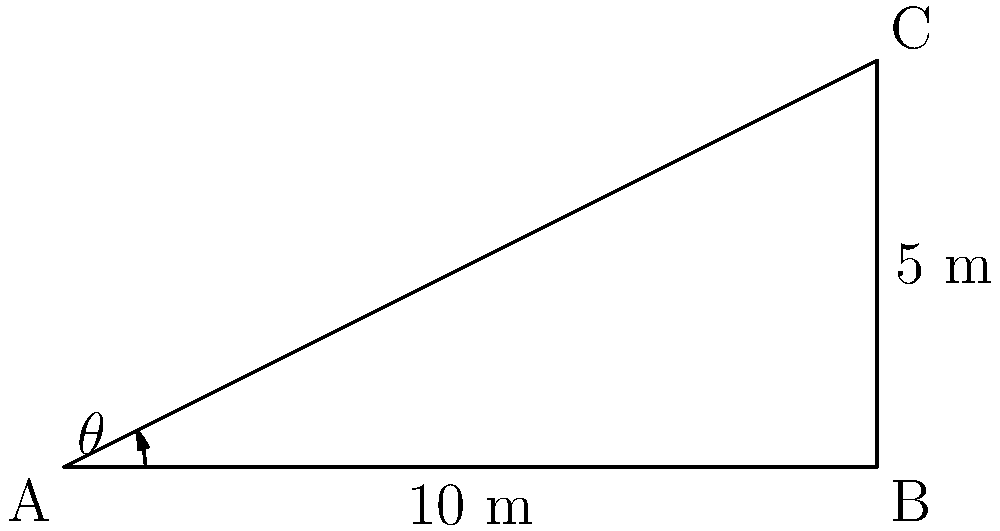An automated sanitizer dispenser needs to be installed at point A to cover a rectangular area of 10 m by 5 m. If the dispenser is placed at ground level (point A) and needs to reach the top corner of the area (point C), what angle $\theta$ should the spray be set at to effectively cover the entire area? To solve this problem, we need to use basic trigonometry. Let's approach this step-by-step:

1) The rectangle forms a right-angled triangle ABC, where:
   - AB is the base (adjacent to angle $\theta$)
   - AC is the hypotenuse
   - BC is the height (opposite to angle $\theta$)

2) We know:
   - AB = 10 m (base)
   - BC = 5 m (height)

3) To find angle $\theta$, we can use the tangent function:

   $\tan(\theta) = \frac{\text{opposite}}{\text{adjacent}} = \frac{BC}{AB} = \frac{5}{10} = 0.5$

4) To get $\theta$, we need to take the inverse tangent (arctangent):

   $\theta = \tan^{-1}(0.5)$

5) Using a calculator or trigonometric tables:

   $\theta \approx 26.57°$

Therefore, the sanitizer dispenser should be set at an angle of approximately 26.57° to effectively cover the entire area.
Answer: $26.57°$ 